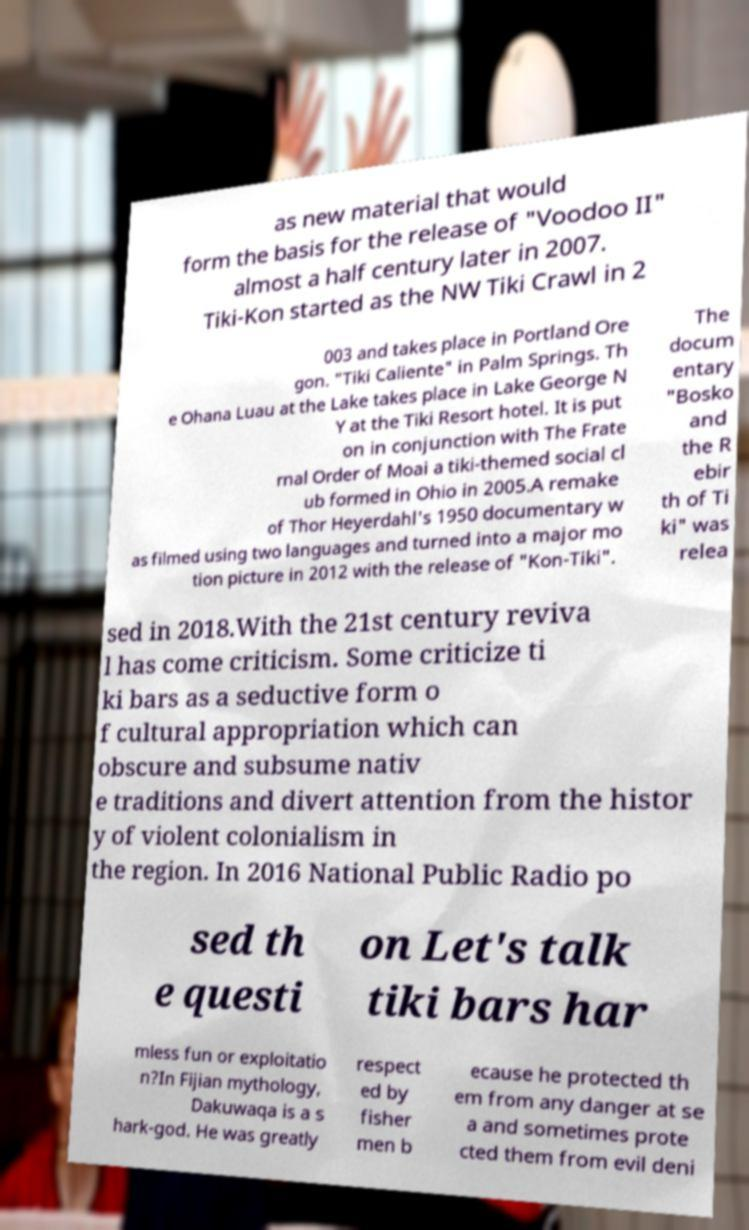Can you read and provide the text displayed in the image?This photo seems to have some interesting text. Can you extract and type it out for me? as new material that would form the basis for the release of "Voodoo II" almost a half century later in 2007. Tiki-Kon started as the NW Tiki Crawl in 2 003 and takes place in Portland Ore gon. "Tiki Caliente" in Palm Springs. Th e Ohana Luau at the Lake takes place in Lake George N Y at the Tiki Resort hotel. It is put on in conjunction with The Frate rnal Order of Moai a tiki-themed social cl ub formed in Ohio in 2005.A remake of Thor Heyerdahl's 1950 documentary w as filmed using two languages and turned into a major mo tion picture in 2012 with the release of "Kon-Tiki". The docum entary "Bosko and the R ebir th of Ti ki" was relea sed in 2018.With the 21st century reviva l has come criticism. Some criticize ti ki bars as a seductive form o f cultural appropriation which can obscure and subsume nativ e traditions and divert attention from the histor y of violent colonialism in the region. In 2016 National Public Radio po sed th e questi on Let's talk tiki bars har mless fun or exploitatio n?In Fijian mythology, Dakuwaqa is a s hark-god. He was greatly respect ed by fisher men b ecause he protected th em from any danger at se a and sometimes prote cted them from evil deni 